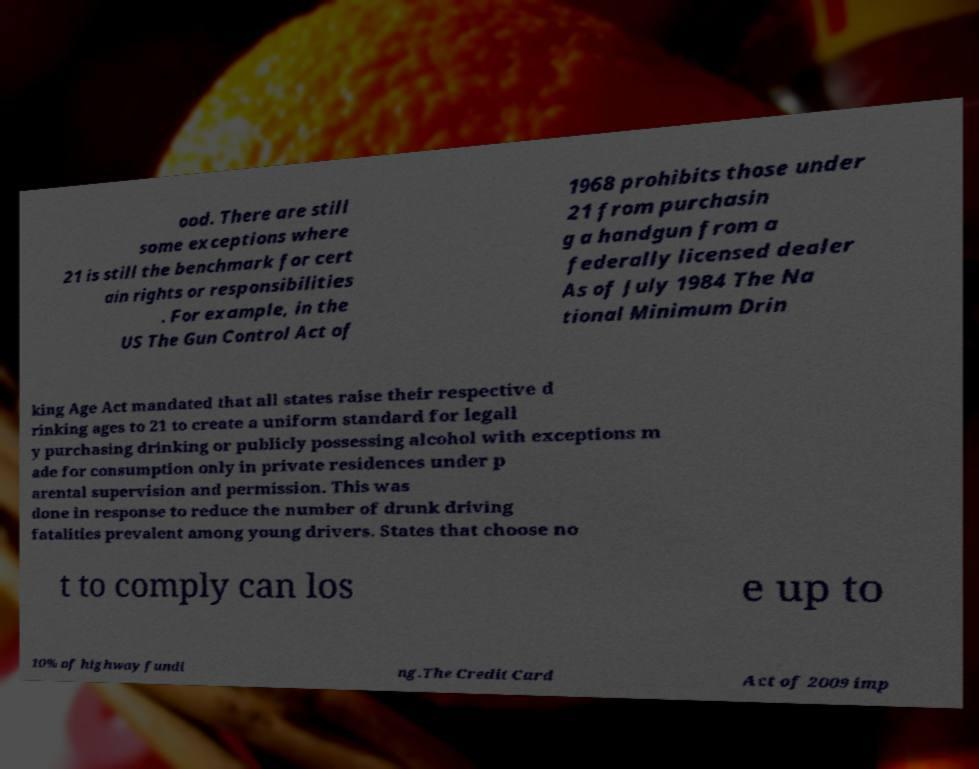For documentation purposes, I need the text within this image transcribed. Could you provide that? ood. There are still some exceptions where 21 is still the benchmark for cert ain rights or responsibilities . For example, in the US The Gun Control Act of 1968 prohibits those under 21 from purchasin g a handgun from a federally licensed dealer As of July 1984 The Na tional Minimum Drin king Age Act mandated that all states raise their respective d rinking ages to 21 to create a uniform standard for legall y purchasing drinking or publicly possessing alcohol with exceptions m ade for consumption only in private residences under p arental supervision and permission. This was done in response to reduce the number of drunk driving fatalities prevalent among young drivers. States that choose no t to comply can los e up to 10% of highway fundi ng.The Credit Card Act of 2009 imp 